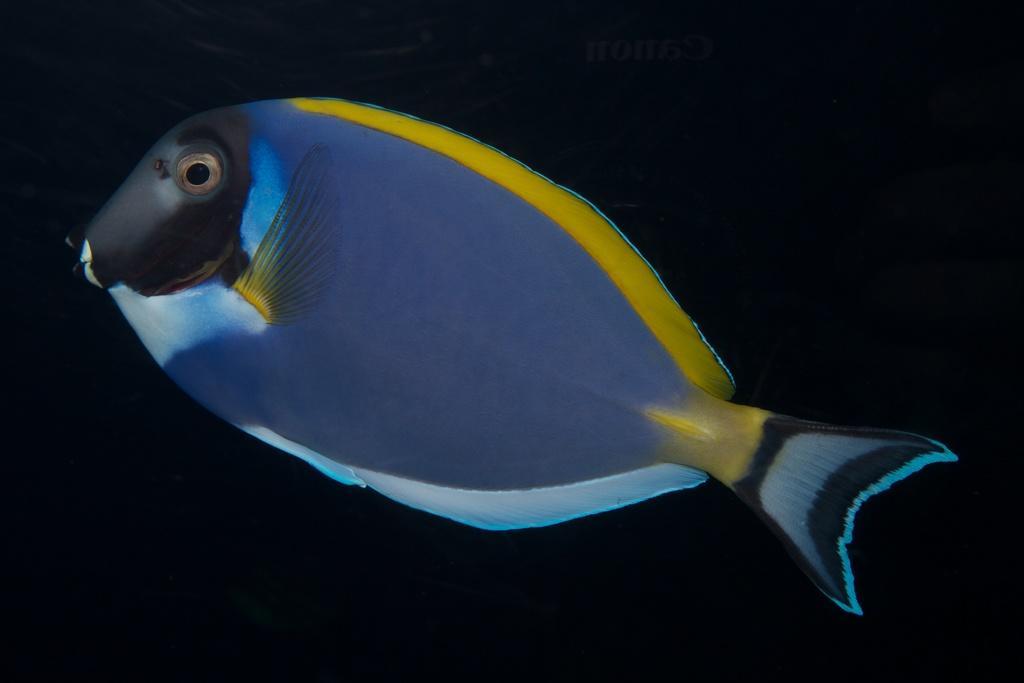Describe this image in one or two sentences. In this picture there is a fish. At the back there is a black background. At the top there is text and the fish is in blue and yellow color. 